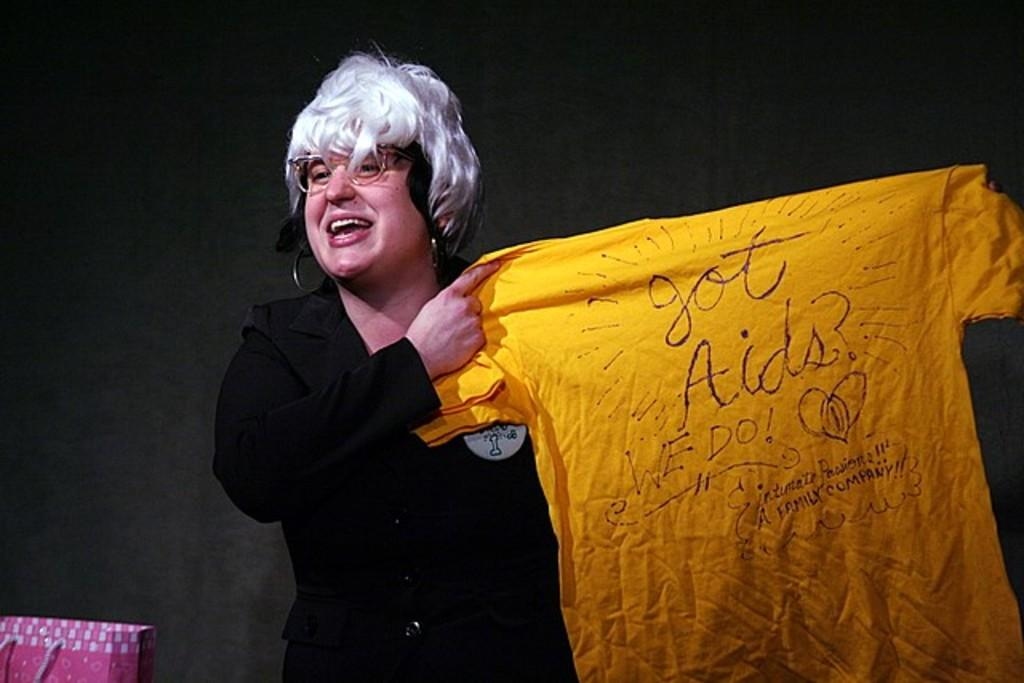Who is present in the image? There is a woman in the image. What is the woman doing in the image? The woman is standing in the image. What is the woman holding in the image? The woman is holding a yellow t-shirt in the image. What is written on the t-shirt? The t-shirt has the text "Got Aids?" and "We do" written on it. What can be seen in the background of the image? There is a pink bag in the background of the image. What type of furniture is visible in the image? There is no furniture visible in the image. What is the rate of the woman's heartbeat in the image? There is no information about the woman's heartbeat in the image. 